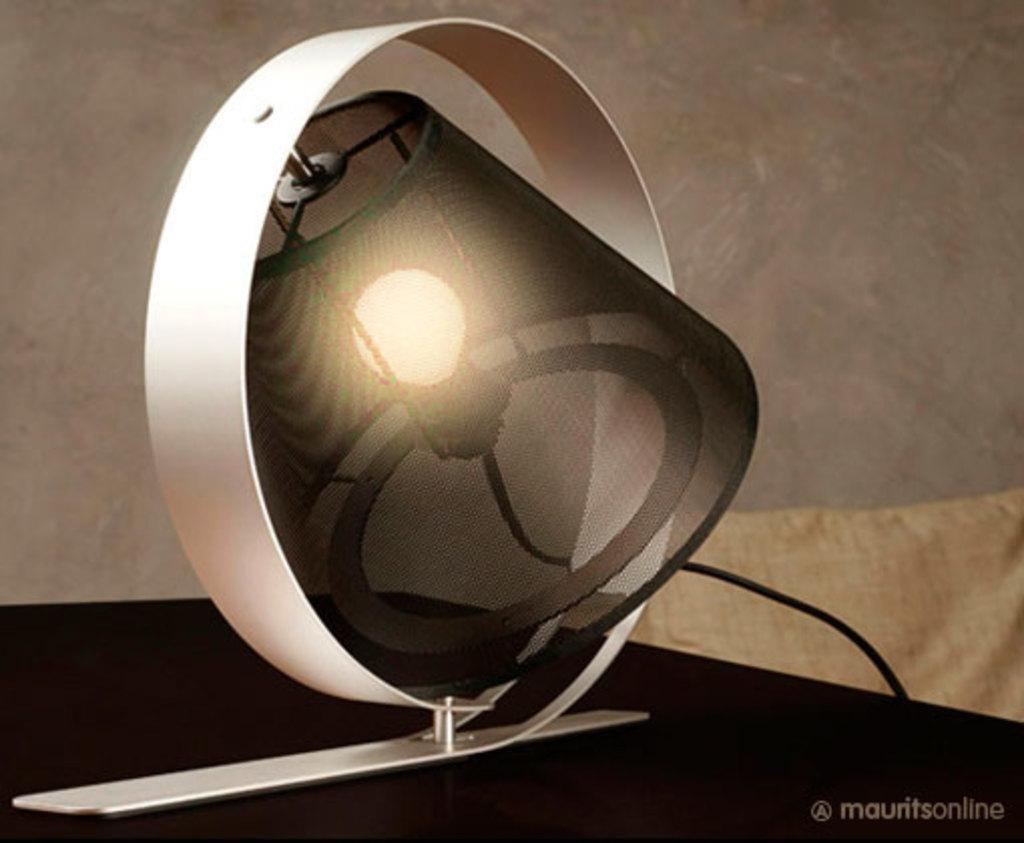How would you summarize this image in a sentence or two? In this image we can see a light object. 